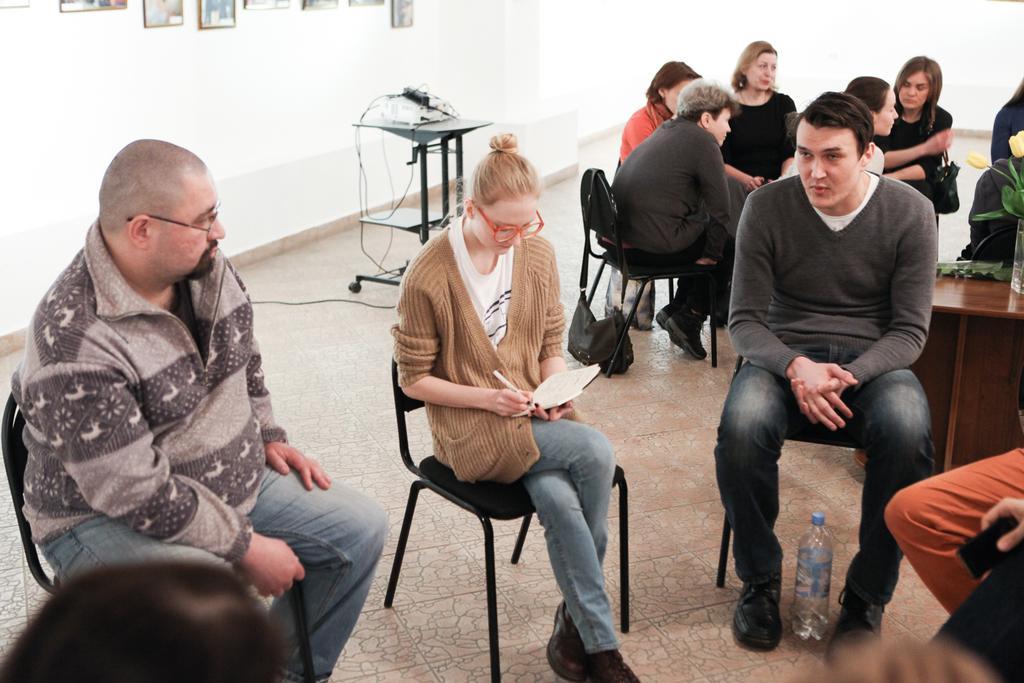Please provide a concise description of this image. I can see in this image a group of people are sitting on chair. I can also see there is a bottle a table, a white color wall with photos and a table on the floor. 